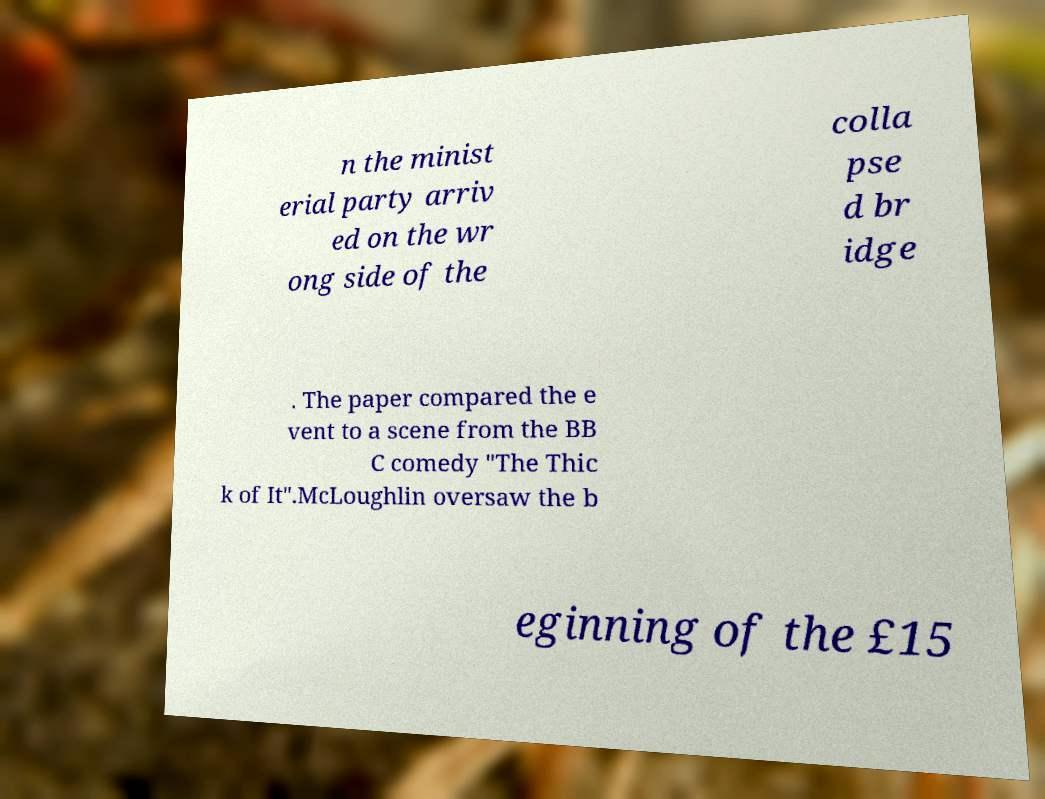What messages or text are displayed in this image? I need them in a readable, typed format. n the minist erial party arriv ed on the wr ong side of the colla pse d br idge . The paper compared the e vent to a scene from the BB C comedy "The Thic k of It".McLoughlin oversaw the b eginning of the £15 